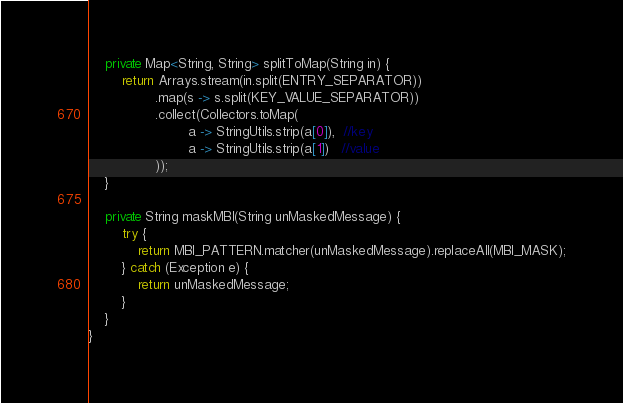Convert code to text. <code><loc_0><loc_0><loc_500><loc_500><_Java_>    private Map<String, String> splitToMap(String in) {
        return Arrays.stream(in.split(ENTRY_SEPARATOR))
                .map(s -> s.split(KEY_VALUE_SEPARATOR))
                .collect(Collectors.toMap(
                        a -> StringUtils.strip(a[0]),  //key
                        a -> StringUtils.strip(a[1])   //value
                ));
    }

    private String maskMBI(String unMaskedMessage) {
        try {
            return MBI_PATTERN.matcher(unMaskedMessage).replaceAll(MBI_MASK);
        } catch (Exception e) {
            return unMaskedMessage;
        }
    }
}
</code> 